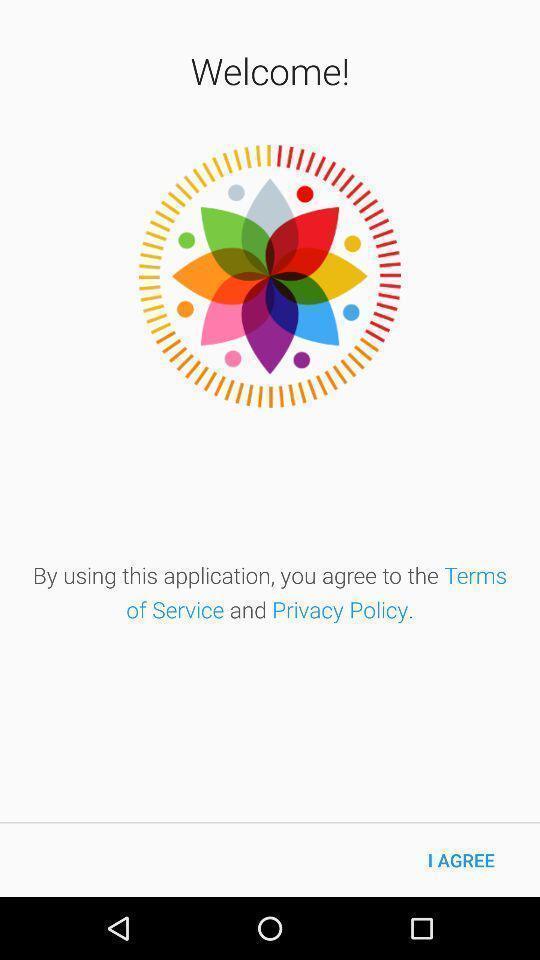Provide a detailed account of this screenshot. Welcome page. 